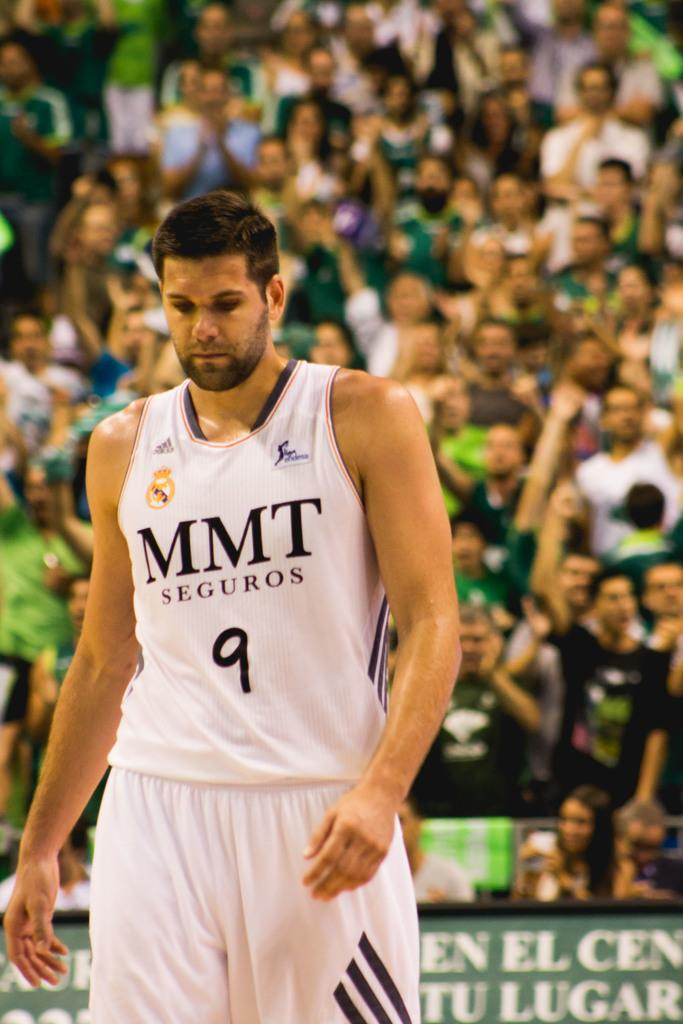Provide a one-sentence caption for the provided image. Athletic play with the jersey mmt seguros wrote on the front. 